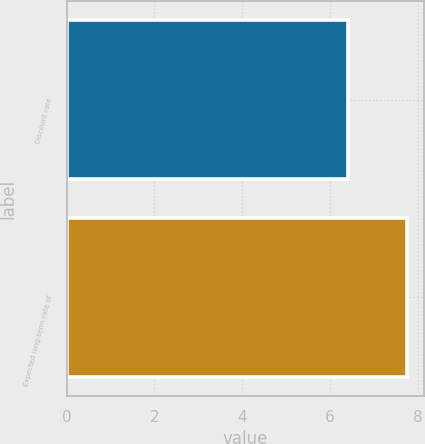Convert chart. <chart><loc_0><loc_0><loc_500><loc_500><bar_chart><fcel>Discount rate<fcel>Expected long-term rate of<nl><fcel>6.41<fcel>7.75<nl></chart> 